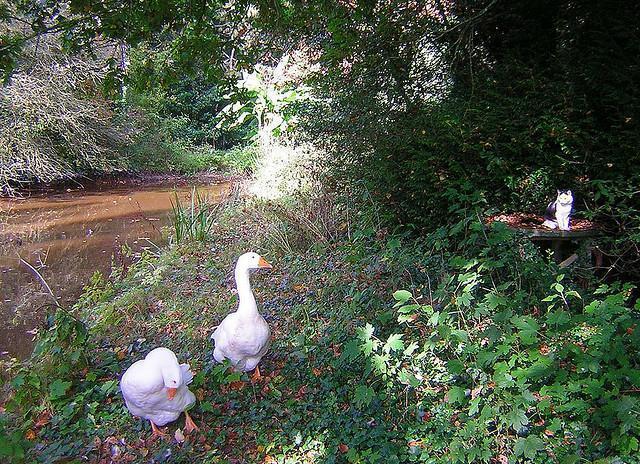Where is the cat staring to?
Indicate the correct response by choosing from the four available options to answer the question.
Options: Ducks, down, right, up. Ducks. 